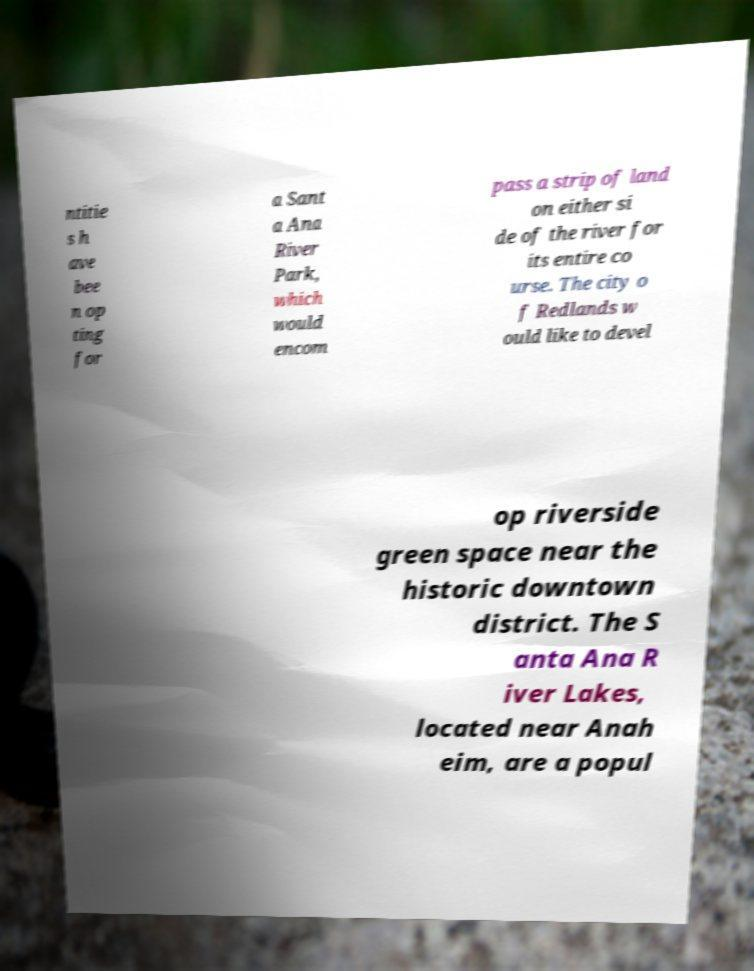There's text embedded in this image that I need extracted. Can you transcribe it verbatim? ntitie s h ave bee n op ting for a Sant a Ana River Park, which would encom pass a strip of land on either si de of the river for its entire co urse. The city o f Redlands w ould like to devel op riverside green space near the historic downtown district. The S anta Ana R iver Lakes, located near Anah eim, are a popul 